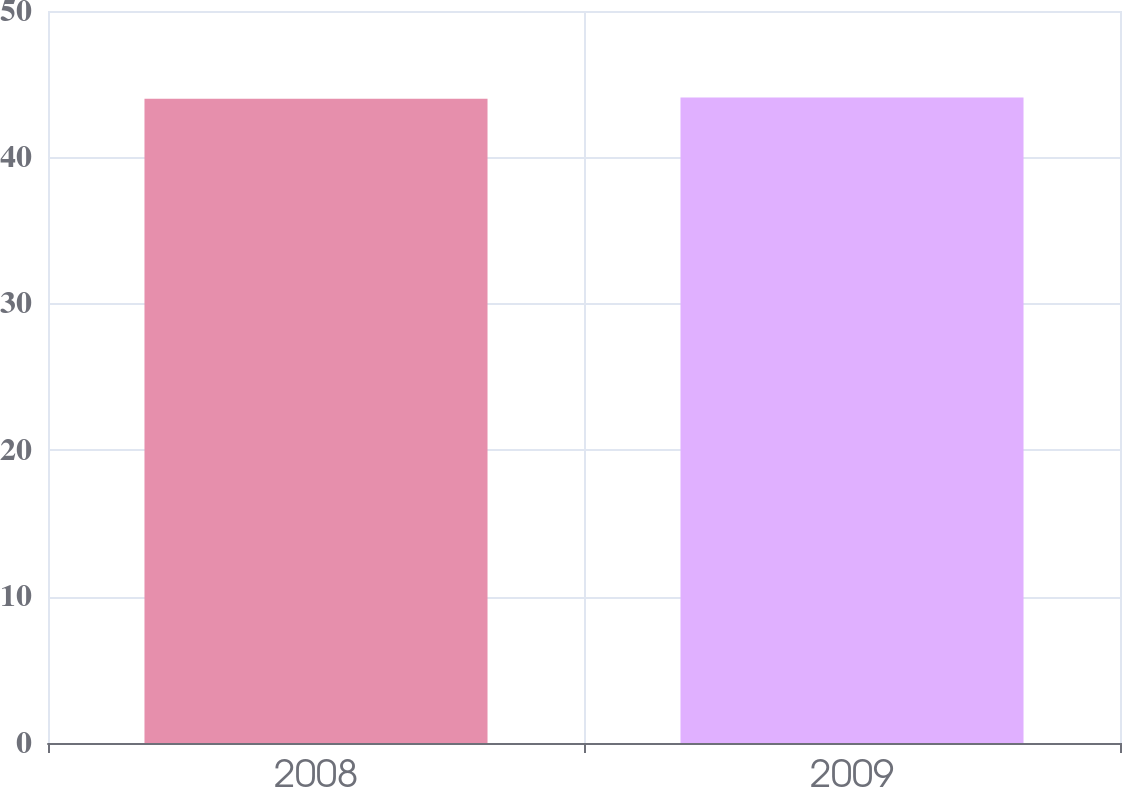<chart> <loc_0><loc_0><loc_500><loc_500><bar_chart><fcel>2008<fcel>2009<nl><fcel>44<fcel>44.1<nl></chart> 